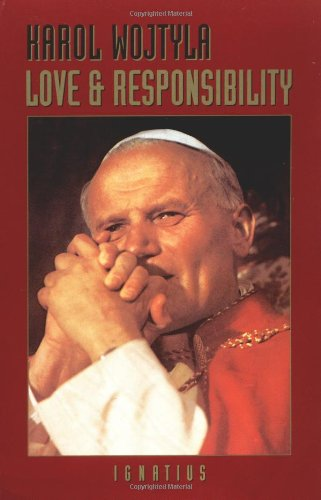What is the title of this book? The title of the book depicted is 'Love and Responsibility.' This work is a comprehensive exploration of the ethical and moral dimensions of human love and relationships. 